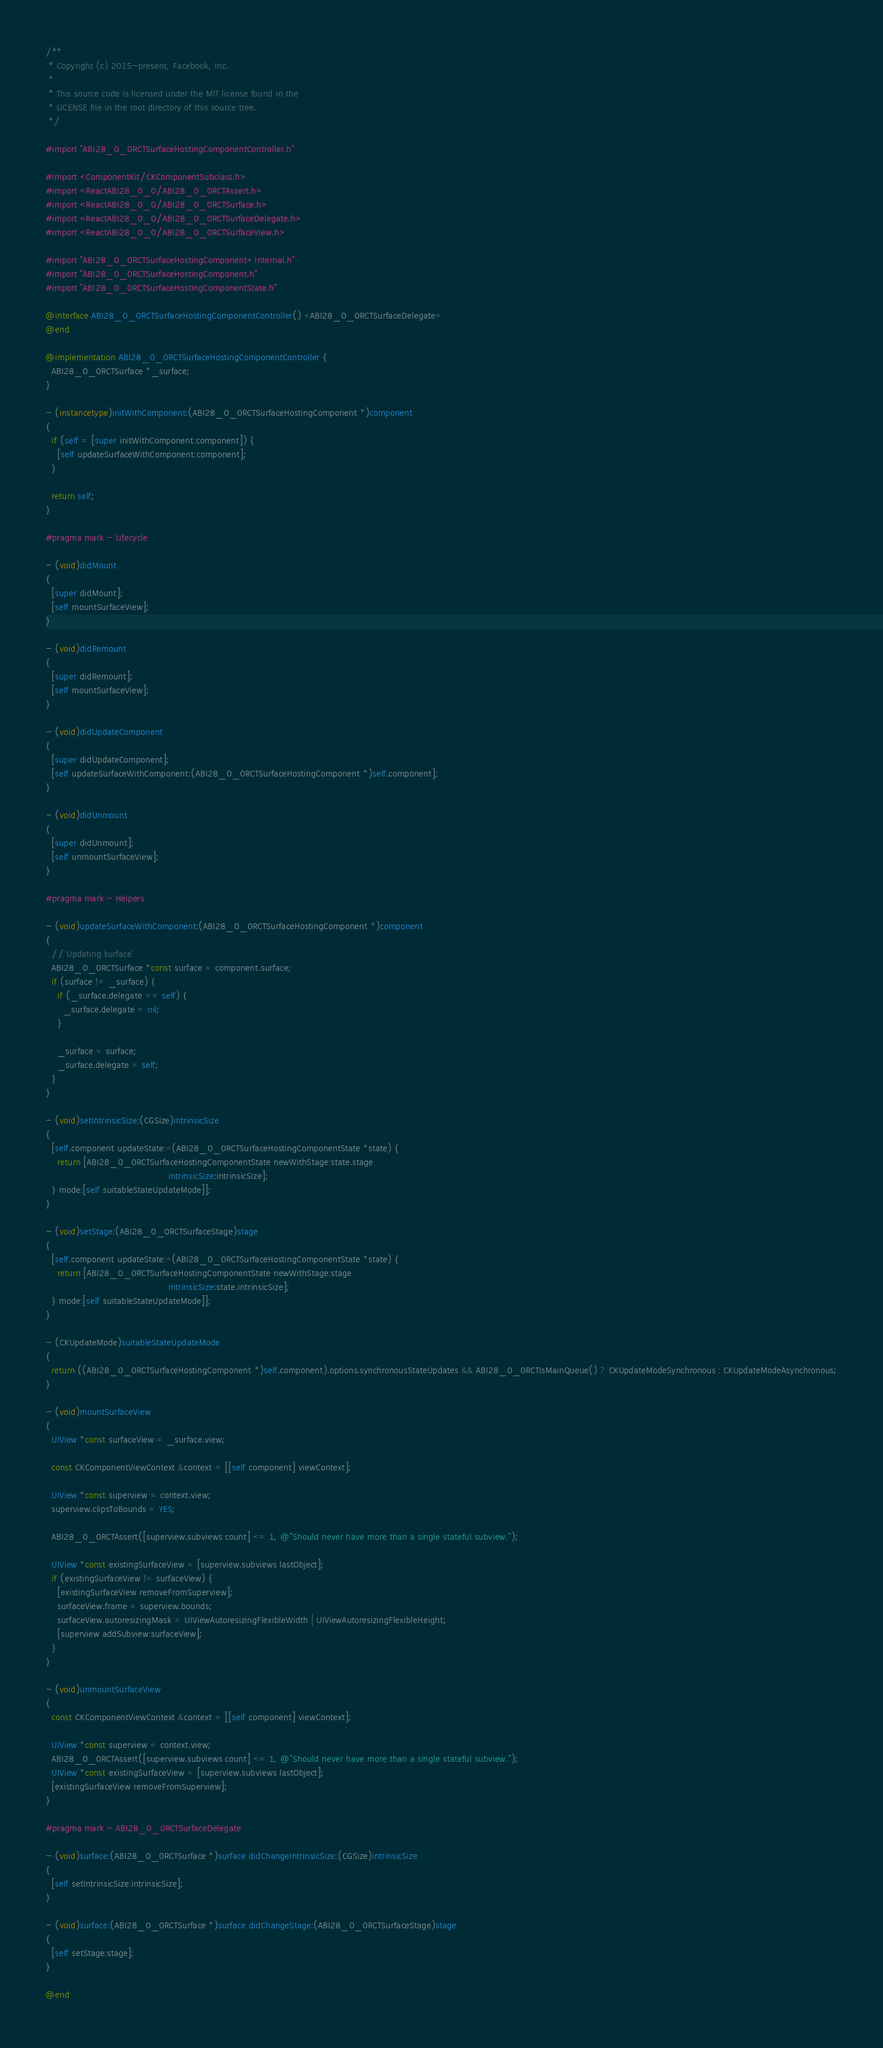Convert code to text. <code><loc_0><loc_0><loc_500><loc_500><_ObjectiveC_>/**
 * Copyright (c) 2015-present, Facebook, Inc.
 *
 * This source code is licensed under the MIT license found in the
 * LICENSE file in the root directory of this source tree.
 */

#import "ABI28_0_0RCTSurfaceHostingComponentController.h"

#import <ComponentKit/CKComponentSubclass.h>
#import <ReactABI28_0_0/ABI28_0_0RCTAssert.h>
#import <ReactABI28_0_0/ABI28_0_0RCTSurface.h>
#import <ReactABI28_0_0/ABI28_0_0RCTSurfaceDelegate.h>
#import <ReactABI28_0_0/ABI28_0_0RCTSurfaceView.h>

#import "ABI28_0_0RCTSurfaceHostingComponent+Internal.h"
#import "ABI28_0_0RCTSurfaceHostingComponent.h"
#import "ABI28_0_0RCTSurfaceHostingComponentState.h"

@interface ABI28_0_0RCTSurfaceHostingComponentController() <ABI28_0_0RCTSurfaceDelegate>
@end

@implementation ABI28_0_0RCTSurfaceHostingComponentController {
  ABI28_0_0RCTSurface *_surface;
}

- (instancetype)initWithComponent:(ABI28_0_0RCTSurfaceHostingComponent *)component
{
  if (self = [super initWithComponent:component]) {
    [self updateSurfaceWithComponent:component];
  }

  return self;
}

#pragma mark - Lifecycle

- (void)didMount
{
  [super didMount];
  [self mountSurfaceView];
}

- (void)didRemount
{
  [super didRemount];
  [self mountSurfaceView];
}

- (void)didUpdateComponent
{
  [super didUpdateComponent];
  [self updateSurfaceWithComponent:(ABI28_0_0RCTSurfaceHostingComponent *)self.component];
}

- (void)didUnmount
{
  [super didUnmount];
  [self unmountSurfaceView];
}

#pragma mark - Helpers

- (void)updateSurfaceWithComponent:(ABI28_0_0RCTSurfaceHostingComponent *)component
{
  // Updating `surface`
  ABI28_0_0RCTSurface *const surface = component.surface;
  if (surface != _surface) {
    if (_surface.delegate == self) {
      _surface.delegate = nil;
    }

    _surface = surface;
    _surface.delegate = self;
  }
}

- (void)setIntrinsicSize:(CGSize)intrinsicSize
{
  [self.component updateState:^(ABI28_0_0RCTSurfaceHostingComponentState *state) {
    return [ABI28_0_0RCTSurfaceHostingComponentState newWithStage:state.stage
                                           intrinsicSize:intrinsicSize];
  } mode:[self suitableStateUpdateMode]];
}

- (void)setStage:(ABI28_0_0RCTSurfaceStage)stage
{
  [self.component updateState:^(ABI28_0_0RCTSurfaceHostingComponentState *state) {
    return [ABI28_0_0RCTSurfaceHostingComponentState newWithStage:stage
                                           intrinsicSize:state.intrinsicSize];
  } mode:[self suitableStateUpdateMode]];
}

- (CKUpdateMode)suitableStateUpdateMode
{
  return ((ABI28_0_0RCTSurfaceHostingComponent *)self.component).options.synchronousStateUpdates && ABI28_0_0RCTIsMainQueue() ? CKUpdateModeSynchronous : CKUpdateModeAsynchronous;
}

- (void)mountSurfaceView
{
  UIView *const surfaceView = _surface.view;

  const CKComponentViewContext &context = [[self component] viewContext];

  UIView *const superview = context.view;
  superview.clipsToBounds = YES;

  ABI28_0_0RCTAssert([superview.subviews count] <= 1, @"Should never have more than a single stateful subview.");

  UIView *const existingSurfaceView = [superview.subviews lastObject];
  if (existingSurfaceView != surfaceView) {
    [existingSurfaceView removeFromSuperview];
    surfaceView.frame = superview.bounds;
    surfaceView.autoresizingMask = UIViewAutoresizingFlexibleWidth | UIViewAutoresizingFlexibleHeight;
    [superview addSubview:surfaceView];
  }
}

- (void)unmountSurfaceView
{
  const CKComponentViewContext &context = [[self component] viewContext];

  UIView *const superview = context.view;
  ABI28_0_0RCTAssert([superview.subviews count] <= 1, @"Should never have more than a single stateful subview.");
  UIView *const existingSurfaceView = [superview.subviews lastObject];
  [existingSurfaceView removeFromSuperview];
}

#pragma mark - ABI28_0_0RCTSurfaceDelegate

- (void)surface:(ABI28_0_0RCTSurface *)surface didChangeIntrinsicSize:(CGSize)intrinsicSize
{
  [self setIntrinsicSize:intrinsicSize];
}

- (void)surface:(ABI28_0_0RCTSurface *)surface didChangeStage:(ABI28_0_0RCTSurfaceStage)stage
{
  [self setStage:stage];
}

@end
</code> 